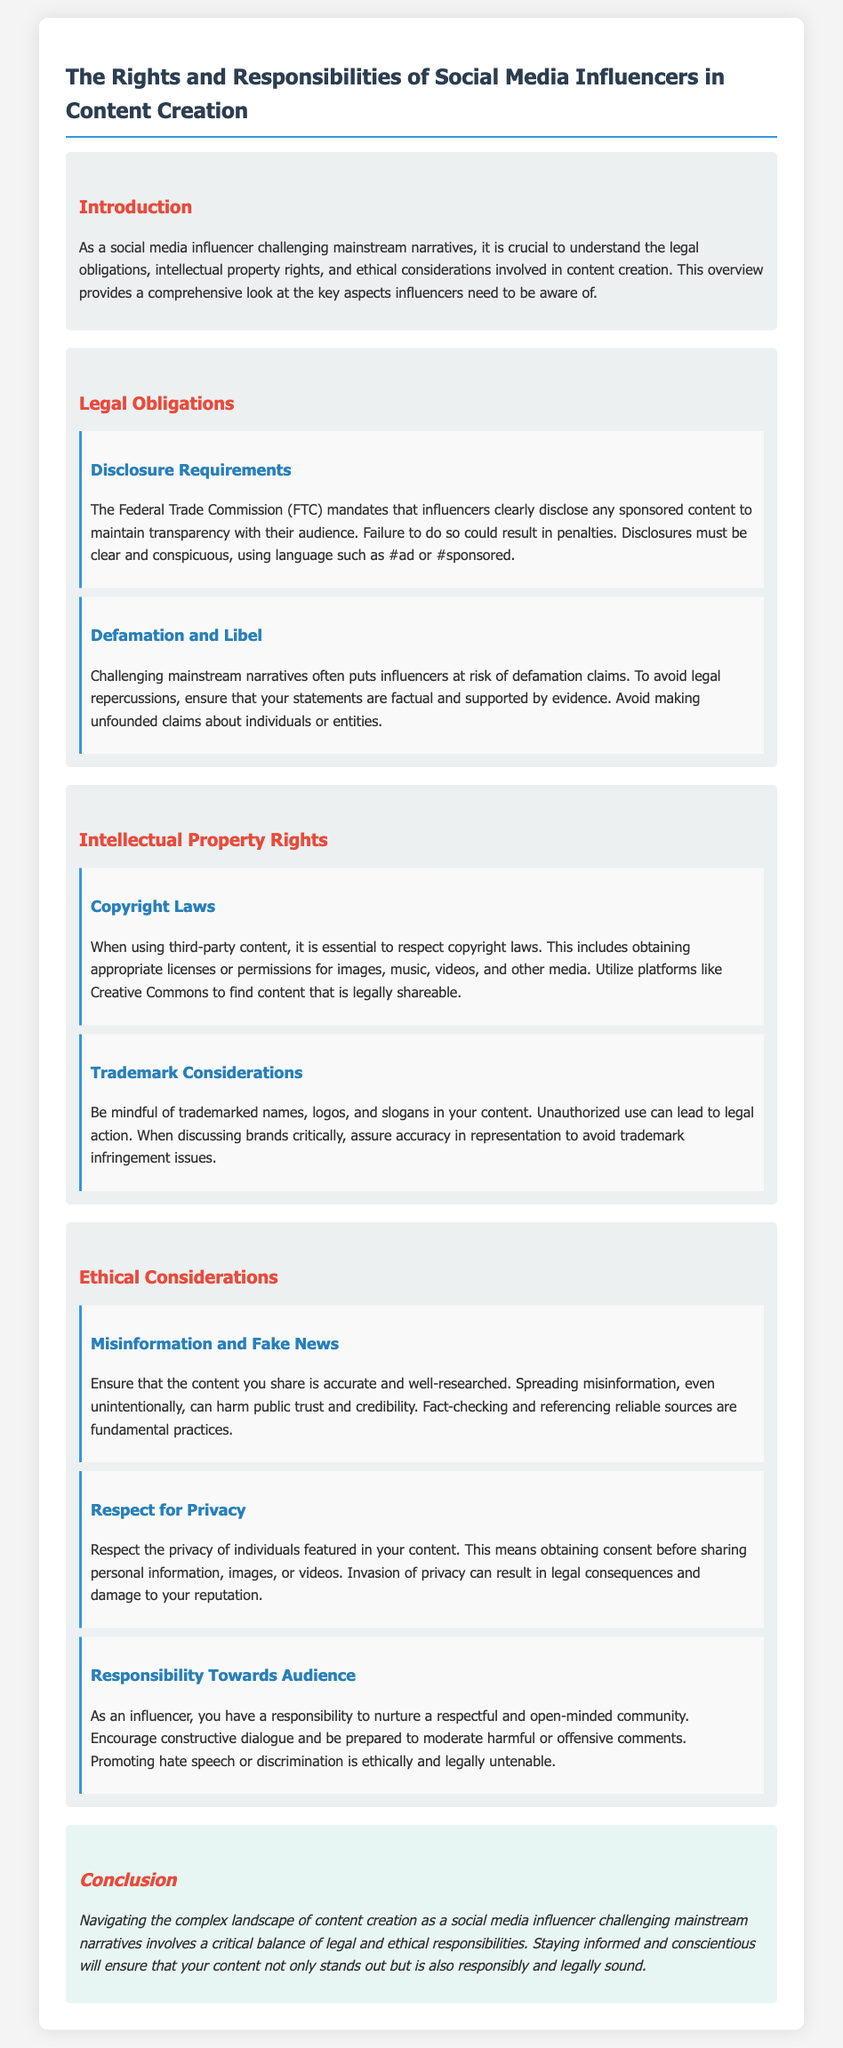What are the FTC disclosure requirements? The FTC mandates that influencers clearly disclose any sponsored content to maintain transparency, using language such as #ad or #sponsored.
Answer: #ad or #sponsored What must influencers avoid to prevent defamation claims? Influencers should ensure that their statements are factual and supported by evidence to avoid making unfounded claims about individuals or entities.
Answer: Factual statements What platforms can influencers use to find legally shareable content? Influencers can utilize platforms like Creative Commons to find content that is legally shareable and respects copyright laws.
Answer: Creative Commons What is one key responsibility of influencers towards their audience? Influencers have the responsibility to nurture a respectful and open-minded community and encourage constructive dialogue.
Answer: Respectful community What can result from invading someone's privacy in content creation? Invasion of privacy can result in legal consequences and damage to the influencer's reputation.
Answer: Legal consequences What legal risk does unauthorized use of trademarks pose? Unauthorized use of trademarked names, logos, and slogans can lead to legal action against the influencer.
Answer: Legal action What is required when using third-party content? It is essential to obtain appropriate licenses or permissions before using third-party content to respect copyright laws.
Answer: Licenses or permissions What should influencers do to avoid spreading misinformation? Influencers should ensure that the content they share is accurate and well-researched, including fact-checking and referencing reliable sources.
Answer: Fact-checking What is one ethical consideration mentioned for influencers? The content shared must be accurate and well-researched to avoid harming public trust and credibility.
Answer: Accurate content 